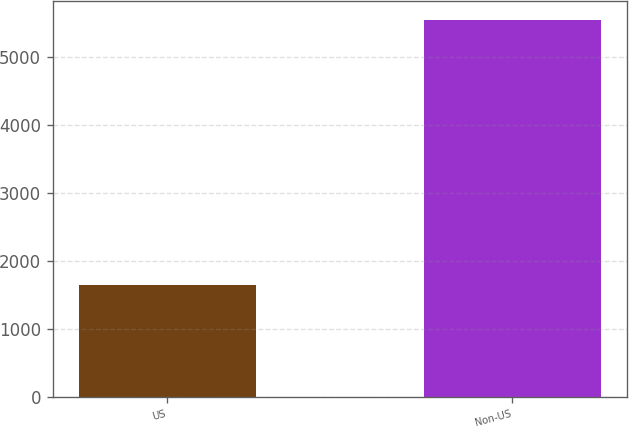Convert chart. <chart><loc_0><loc_0><loc_500><loc_500><bar_chart><fcel>US<fcel>Non-US<nl><fcel>1645<fcel>5546<nl></chart> 